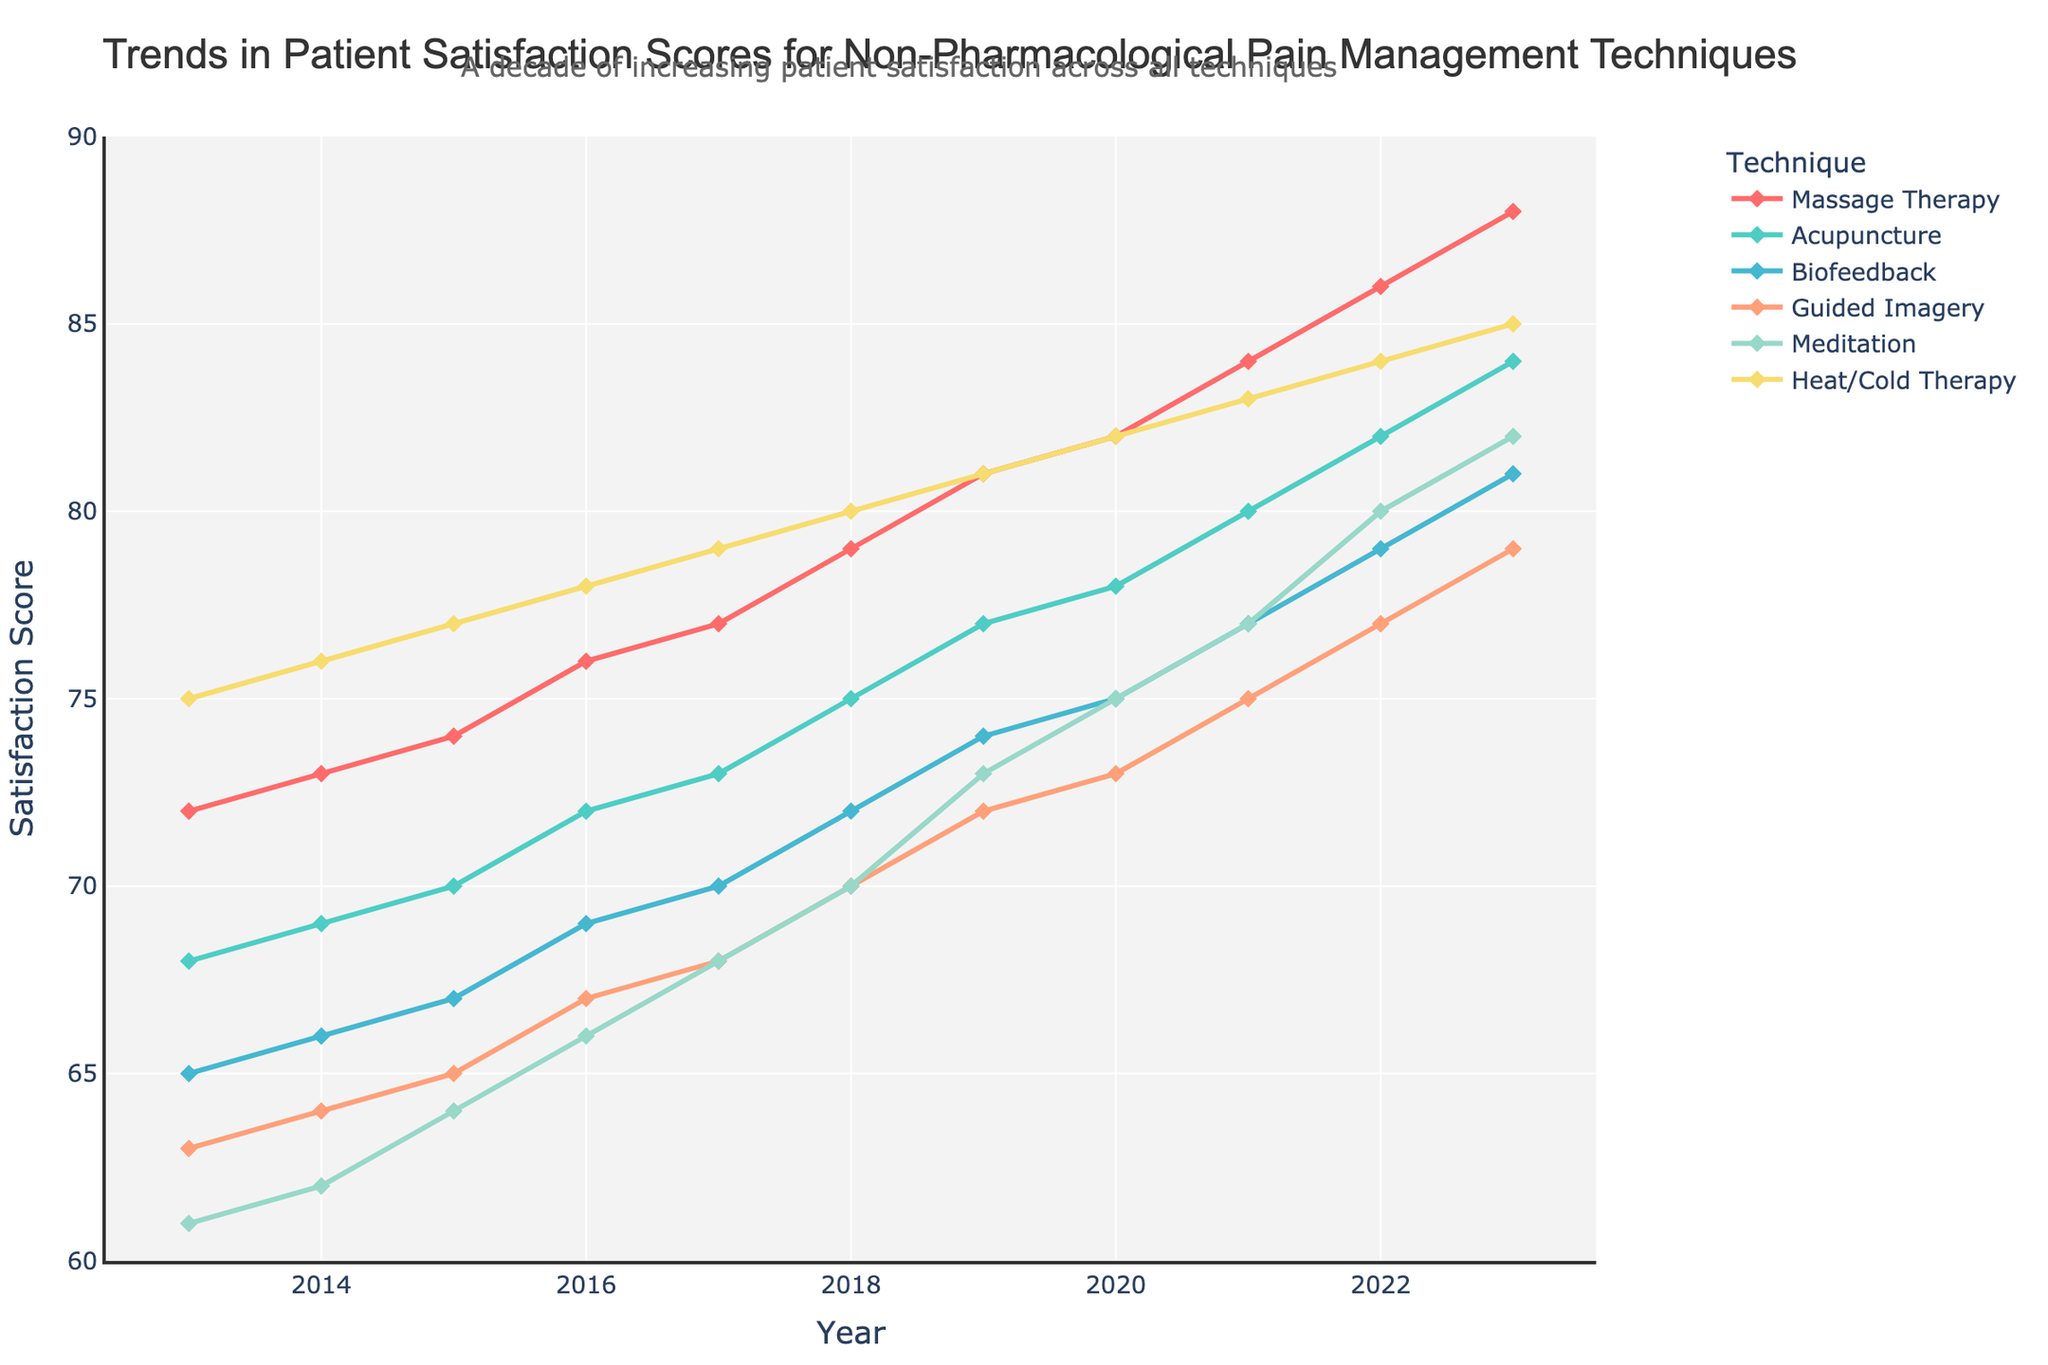what is the highest satisfaction score for Massage Therapy and in which year was it recorded? The highest satisfaction score for Massage Therapy can be observed at the peak of the Massage Therapy curve. By looking at the ending of the Massage Therapy line on the y-axis, the highest score is 88, which corresponds to the year 2023.
Answer: 2023 How does the patient satisfaction score of Heat/Cold Therapy in 2020 compare to Meditation in 2020? Examine the y-axis values for Heat/Cold Therapy and Meditation in 2020. The score for Heat/Cold Therapy is 82, whereas the score for Meditation is 75. Therefore, Heat/Cold Therapy has a higher score than Meditation for that year.
Answer: Heat/Cold Therapy has higher satisfaction Which non-pharmacological pain management technique had the lowest satisfaction score in 2013? Survey the y-axis values for all techniques in 2013. The lowest score among them is 61 for Meditation.
Answer: Meditation Which techniques showed a consistent increase in patient satisfaction scores every year? Analyze the line patterns for each technique from 2013 to 2023. Techniques that consistently rise every year are Massage Therapy, Acupuncture, Biofeedback, Guided Imagery, Meditation, and Heat/Cold Therapy. Each line shows an upward trend without any drops.
Answer: All techniques What is the average satisfaction score for Biofeedback from 2018 to 2023? Find the scores for Biofeedback from 2018 to 2023 which are 72, 74, 75, 77, 79, and 81. Sum these values (72 + 74 + 75 + 77 + 79 + 81 = 458) and divide by the number of years (6) to get the average: 458/6 = 76.33.
Answer: 76.33 What is the difference between the highest and lowest satisfaction scores for Massage Therapy? Identify the highest score (88 in 2023) and the lowest score (72 in 2013) for Massage Therapy. Subtract the lowest from the highest (88 - 72 = 16).
Answer: 16 points Between 2016 and 2018, which technique showed the highest increase in patient satisfaction scores? Observe the differences in satisfaction scores between 2016 and 2018 for each technique: Massage Therapy (79-76=3), Acupuncture (75-72=3), Biofeedback (72-69=3), Guided Imagery (70-67=3), Meditation (70-66=4), Heat/Cold Therapy (80-78=2). Meditation showed the highest increase (4 points).
Answer: Meditation 